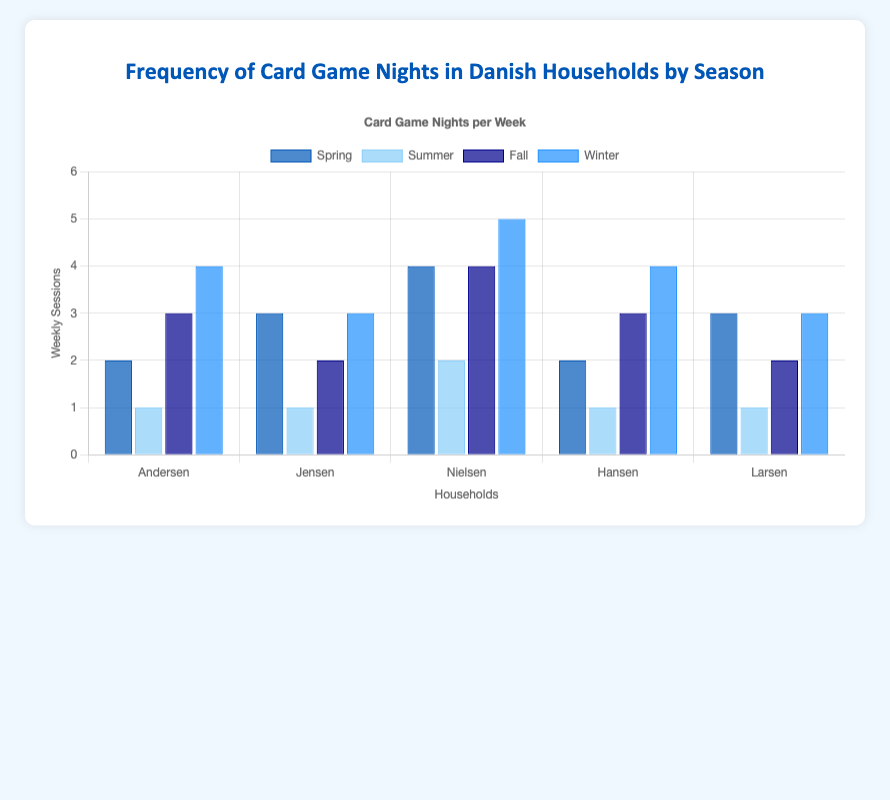Which household has the highest frequency of card game nights during Winter? Look for the marked height of the bars in the Winter section and compare them. "Nielsen" has the tallest bar with 5 weekly sessions.
Answer: Nielsen What is the total number of weekly sessions for Spring across all households? Sum the weekly sessions for each household in Spring: 2 (Andersen) + 3 (Jensen) + 4 (Nielsen) + 2 (Hansen) + 3 (Larsen) = 14.
Answer: 14 Which season has the lowest average weekly sessions for card game nights across all households? Calculate the averages for each season and compare them:
Spring: (2+3+4+2+3)/5 = 2.8
Summer: (1+1+2+1+1)/5 = 1.2
Fall: (3+2+4+3+2)/5 = 2.8
Winter: (4+3+5+4+3)/5 = 3.8
Summer has the lowest average weekly sessions, with 1.2.
Answer: Summer Is there any household that has the same weekly session frequency across two different seasons? Check each household's weekly sessions across all seasons to identify any matching values:
Andersen: 2 (Spring), 1 (Summer), 3 (Fall), 4 (Winter)
Jensen: 3 (Spring), 1 (Summer), 2 (Fall), 3 (Winter)
Nielsen: 4 (Spring), 2 (Summer), 4 (Fall), 5 (Winter)
Hansen: 2 (Spring), 1 (Summer), 3 (Fall), 4 (Winter)
Larsen: 3 (Spring), 1 (Summer), 2 (Fall), 3 (Winter)
Yes, "Jensen" has 3 sessions in both Spring and Winter.
Answer: Jensen Which household shows the greatest increase in weekly card game sessions from Summer to Winter? Calculate the increase for each household from Summer to Winter and identify the greatest increase:
Andersen: 4 - 1 = 3
Jensen: 3 - 1 = 2
Nielsen: 5 - 2 = 3
Hansen: 4 - 1 = 3
Larsen: 3 - 1 = 2
Andersen, Nielsen, and Hansen show the same greatest increase of 3.
Answer: Andersen, Nielsen, Hansen Compare the number of weekly card game sessions in Fall for "Hansen" and "Larsen." Who has more sessions? Identify and compare the heights of the bars in Fall for "Hansen" and "Larsen." Hansen has 3 weekly sessions, whereas Larsen has 2.
Answer: Hansen What is the difference in weekly sessions between the busiest season and the least busy season for "Nielsen"? Calculate the difference in sessions for "Nielsen" between Winter (busiest) and Summer (least busy): 5 (Winter) - 2 (Summer) = 3.
Answer: 3 In which season do households collectively have 15 weekly sessions in total? Sum the sessions for each season and find the one equaling 15:
Spring: 14
Summer: 6
Fall: 14
Winter: 19
No season matches the total of 15 weekly sessions.
Answer: None What is the median weekly session count for "Larsen" across all seasons? Arrange Larsen's weekly session counts in ascending order: 1, 1, 2, 3, 3. The median value is the third in the list: 2.
Answer: 2 